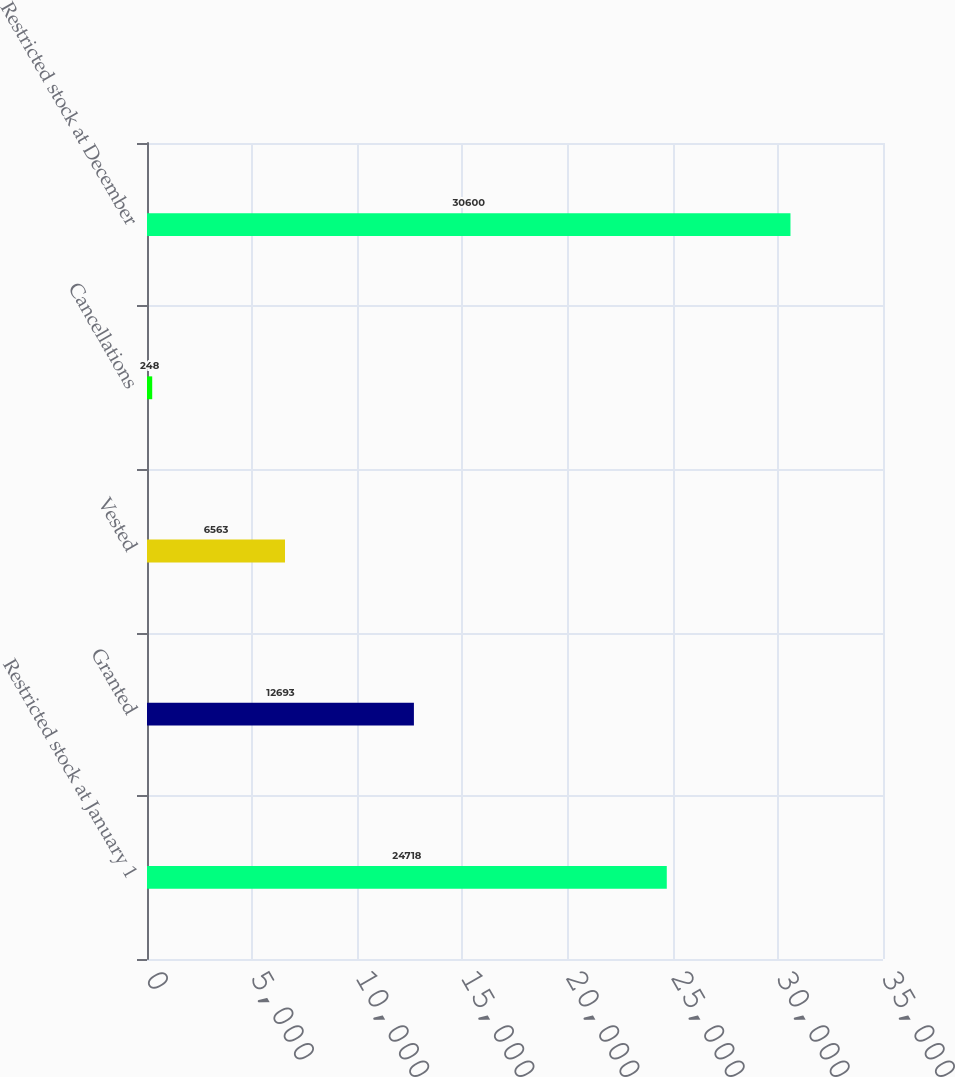Convert chart to OTSL. <chart><loc_0><loc_0><loc_500><loc_500><bar_chart><fcel>Restricted stock at January 1<fcel>Granted<fcel>Vested<fcel>Cancellations<fcel>Restricted stock at December<nl><fcel>24718<fcel>12693<fcel>6563<fcel>248<fcel>30600<nl></chart> 